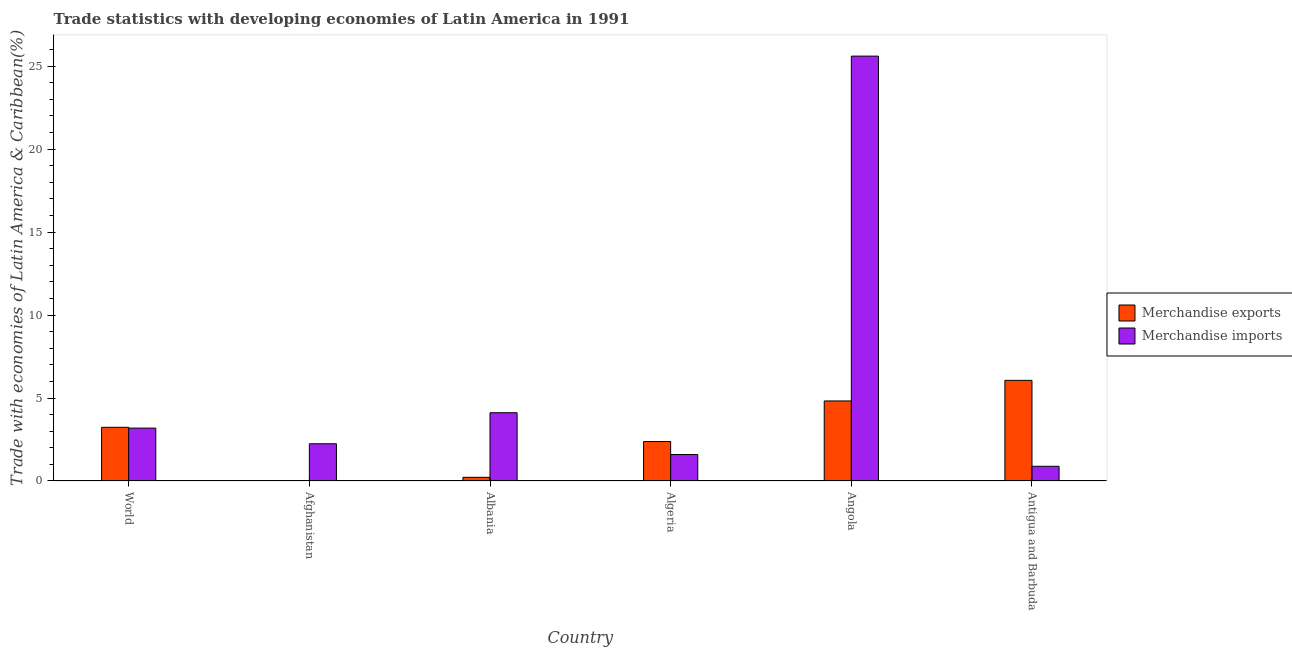How many groups of bars are there?
Give a very brief answer. 6. Are the number of bars on each tick of the X-axis equal?
Give a very brief answer. Yes. How many bars are there on the 5th tick from the right?
Your answer should be compact. 2. What is the label of the 1st group of bars from the left?
Offer a very short reply. World. In how many cases, is the number of bars for a given country not equal to the number of legend labels?
Offer a very short reply. 0. What is the merchandise exports in Angola?
Make the answer very short. 4.82. Across all countries, what is the maximum merchandise exports?
Provide a short and direct response. 6.06. Across all countries, what is the minimum merchandise imports?
Keep it short and to the point. 0.89. In which country was the merchandise imports maximum?
Provide a succinct answer. Angola. In which country was the merchandise exports minimum?
Offer a very short reply. Afghanistan. What is the total merchandise imports in the graph?
Offer a very short reply. 37.63. What is the difference between the merchandise imports in Afghanistan and that in Albania?
Offer a very short reply. -1.87. What is the difference between the merchandise imports in Angola and the merchandise exports in Algeria?
Ensure brevity in your answer.  23.22. What is the average merchandise exports per country?
Make the answer very short. 2.79. What is the difference between the merchandise imports and merchandise exports in World?
Offer a very short reply. -0.05. What is the ratio of the merchandise imports in Afghanistan to that in Albania?
Keep it short and to the point. 0.55. Is the difference between the merchandise imports in Albania and World greater than the difference between the merchandise exports in Albania and World?
Keep it short and to the point. Yes. What is the difference between the highest and the second highest merchandise exports?
Provide a short and direct response. 1.24. What is the difference between the highest and the lowest merchandise imports?
Provide a short and direct response. 24.72. Is the sum of the merchandise exports in Afghanistan and Angola greater than the maximum merchandise imports across all countries?
Provide a succinct answer. No. What does the 1st bar from the left in Antigua and Barbuda represents?
Make the answer very short. Merchandise exports. What does the 2nd bar from the right in Albania represents?
Make the answer very short. Merchandise exports. Does the graph contain any zero values?
Ensure brevity in your answer.  No. What is the title of the graph?
Ensure brevity in your answer.  Trade statistics with developing economies of Latin America in 1991. What is the label or title of the Y-axis?
Ensure brevity in your answer.  Trade with economies of Latin America & Caribbean(%). What is the Trade with economies of Latin America & Caribbean(%) in Merchandise exports in World?
Give a very brief answer. 3.23. What is the Trade with economies of Latin America & Caribbean(%) of Merchandise imports in World?
Ensure brevity in your answer.  3.19. What is the Trade with economies of Latin America & Caribbean(%) in Merchandise exports in Afghanistan?
Offer a terse response. 0.01. What is the Trade with economies of Latin America & Caribbean(%) in Merchandise imports in Afghanistan?
Your answer should be very brief. 2.24. What is the Trade with economies of Latin America & Caribbean(%) of Merchandise exports in Albania?
Make the answer very short. 0.22. What is the Trade with economies of Latin America & Caribbean(%) of Merchandise imports in Albania?
Give a very brief answer. 4.11. What is the Trade with economies of Latin America & Caribbean(%) in Merchandise exports in Algeria?
Make the answer very short. 2.38. What is the Trade with economies of Latin America & Caribbean(%) of Merchandise imports in Algeria?
Provide a succinct answer. 1.59. What is the Trade with economies of Latin America & Caribbean(%) of Merchandise exports in Angola?
Keep it short and to the point. 4.82. What is the Trade with economies of Latin America & Caribbean(%) of Merchandise imports in Angola?
Offer a very short reply. 25.6. What is the Trade with economies of Latin America & Caribbean(%) in Merchandise exports in Antigua and Barbuda?
Your answer should be compact. 6.06. What is the Trade with economies of Latin America & Caribbean(%) in Merchandise imports in Antigua and Barbuda?
Make the answer very short. 0.89. Across all countries, what is the maximum Trade with economies of Latin America & Caribbean(%) of Merchandise exports?
Your response must be concise. 6.06. Across all countries, what is the maximum Trade with economies of Latin America & Caribbean(%) in Merchandise imports?
Provide a short and direct response. 25.6. Across all countries, what is the minimum Trade with economies of Latin America & Caribbean(%) in Merchandise exports?
Give a very brief answer. 0.01. Across all countries, what is the minimum Trade with economies of Latin America & Caribbean(%) in Merchandise imports?
Offer a terse response. 0.89. What is the total Trade with economies of Latin America & Caribbean(%) of Merchandise exports in the graph?
Give a very brief answer. 16.73. What is the total Trade with economies of Latin America & Caribbean(%) in Merchandise imports in the graph?
Make the answer very short. 37.63. What is the difference between the Trade with economies of Latin America & Caribbean(%) of Merchandise exports in World and that in Afghanistan?
Offer a terse response. 3.22. What is the difference between the Trade with economies of Latin America & Caribbean(%) in Merchandise imports in World and that in Afghanistan?
Provide a succinct answer. 0.94. What is the difference between the Trade with economies of Latin America & Caribbean(%) of Merchandise exports in World and that in Albania?
Your response must be concise. 3.01. What is the difference between the Trade with economies of Latin America & Caribbean(%) in Merchandise imports in World and that in Albania?
Provide a short and direct response. -0.92. What is the difference between the Trade with economies of Latin America & Caribbean(%) in Merchandise exports in World and that in Algeria?
Ensure brevity in your answer.  0.86. What is the difference between the Trade with economies of Latin America & Caribbean(%) of Merchandise imports in World and that in Algeria?
Provide a succinct answer. 1.59. What is the difference between the Trade with economies of Latin America & Caribbean(%) in Merchandise exports in World and that in Angola?
Provide a short and direct response. -1.59. What is the difference between the Trade with economies of Latin America & Caribbean(%) of Merchandise imports in World and that in Angola?
Ensure brevity in your answer.  -22.42. What is the difference between the Trade with economies of Latin America & Caribbean(%) in Merchandise exports in World and that in Antigua and Barbuda?
Your answer should be compact. -2.83. What is the difference between the Trade with economies of Latin America & Caribbean(%) in Merchandise imports in World and that in Antigua and Barbuda?
Give a very brief answer. 2.3. What is the difference between the Trade with economies of Latin America & Caribbean(%) in Merchandise exports in Afghanistan and that in Albania?
Give a very brief answer. -0.21. What is the difference between the Trade with economies of Latin America & Caribbean(%) in Merchandise imports in Afghanistan and that in Albania?
Your answer should be compact. -1.87. What is the difference between the Trade with economies of Latin America & Caribbean(%) of Merchandise exports in Afghanistan and that in Algeria?
Make the answer very short. -2.37. What is the difference between the Trade with economies of Latin America & Caribbean(%) in Merchandise imports in Afghanistan and that in Algeria?
Offer a terse response. 0.65. What is the difference between the Trade with economies of Latin America & Caribbean(%) of Merchandise exports in Afghanistan and that in Angola?
Make the answer very short. -4.81. What is the difference between the Trade with economies of Latin America & Caribbean(%) in Merchandise imports in Afghanistan and that in Angola?
Offer a terse response. -23.36. What is the difference between the Trade with economies of Latin America & Caribbean(%) in Merchandise exports in Afghanistan and that in Antigua and Barbuda?
Offer a terse response. -6.05. What is the difference between the Trade with economies of Latin America & Caribbean(%) of Merchandise imports in Afghanistan and that in Antigua and Barbuda?
Provide a short and direct response. 1.36. What is the difference between the Trade with economies of Latin America & Caribbean(%) in Merchandise exports in Albania and that in Algeria?
Provide a short and direct response. -2.16. What is the difference between the Trade with economies of Latin America & Caribbean(%) of Merchandise imports in Albania and that in Algeria?
Provide a short and direct response. 2.52. What is the difference between the Trade with economies of Latin America & Caribbean(%) in Merchandise exports in Albania and that in Angola?
Ensure brevity in your answer.  -4.6. What is the difference between the Trade with economies of Latin America & Caribbean(%) of Merchandise imports in Albania and that in Angola?
Provide a succinct answer. -21.49. What is the difference between the Trade with economies of Latin America & Caribbean(%) of Merchandise exports in Albania and that in Antigua and Barbuda?
Provide a short and direct response. -5.84. What is the difference between the Trade with economies of Latin America & Caribbean(%) of Merchandise imports in Albania and that in Antigua and Barbuda?
Provide a succinct answer. 3.23. What is the difference between the Trade with economies of Latin America & Caribbean(%) in Merchandise exports in Algeria and that in Angola?
Your response must be concise. -2.44. What is the difference between the Trade with economies of Latin America & Caribbean(%) of Merchandise imports in Algeria and that in Angola?
Offer a terse response. -24.01. What is the difference between the Trade with economies of Latin America & Caribbean(%) of Merchandise exports in Algeria and that in Antigua and Barbuda?
Keep it short and to the point. -3.68. What is the difference between the Trade with economies of Latin America & Caribbean(%) of Merchandise imports in Algeria and that in Antigua and Barbuda?
Give a very brief answer. 0.71. What is the difference between the Trade with economies of Latin America & Caribbean(%) in Merchandise exports in Angola and that in Antigua and Barbuda?
Give a very brief answer. -1.24. What is the difference between the Trade with economies of Latin America & Caribbean(%) of Merchandise imports in Angola and that in Antigua and Barbuda?
Keep it short and to the point. 24.72. What is the difference between the Trade with economies of Latin America & Caribbean(%) in Merchandise exports in World and the Trade with economies of Latin America & Caribbean(%) in Merchandise imports in Afghanistan?
Your answer should be very brief. 0.99. What is the difference between the Trade with economies of Latin America & Caribbean(%) of Merchandise exports in World and the Trade with economies of Latin America & Caribbean(%) of Merchandise imports in Albania?
Your response must be concise. -0.88. What is the difference between the Trade with economies of Latin America & Caribbean(%) of Merchandise exports in World and the Trade with economies of Latin America & Caribbean(%) of Merchandise imports in Algeria?
Your answer should be compact. 1.64. What is the difference between the Trade with economies of Latin America & Caribbean(%) of Merchandise exports in World and the Trade with economies of Latin America & Caribbean(%) of Merchandise imports in Angola?
Offer a terse response. -22.37. What is the difference between the Trade with economies of Latin America & Caribbean(%) in Merchandise exports in World and the Trade with economies of Latin America & Caribbean(%) in Merchandise imports in Antigua and Barbuda?
Your answer should be compact. 2.35. What is the difference between the Trade with economies of Latin America & Caribbean(%) of Merchandise exports in Afghanistan and the Trade with economies of Latin America & Caribbean(%) of Merchandise imports in Albania?
Make the answer very short. -4.1. What is the difference between the Trade with economies of Latin America & Caribbean(%) in Merchandise exports in Afghanistan and the Trade with economies of Latin America & Caribbean(%) in Merchandise imports in Algeria?
Your response must be concise. -1.58. What is the difference between the Trade with economies of Latin America & Caribbean(%) in Merchandise exports in Afghanistan and the Trade with economies of Latin America & Caribbean(%) in Merchandise imports in Angola?
Give a very brief answer. -25.59. What is the difference between the Trade with economies of Latin America & Caribbean(%) in Merchandise exports in Afghanistan and the Trade with economies of Latin America & Caribbean(%) in Merchandise imports in Antigua and Barbuda?
Offer a terse response. -0.88. What is the difference between the Trade with economies of Latin America & Caribbean(%) in Merchandise exports in Albania and the Trade with economies of Latin America & Caribbean(%) in Merchandise imports in Algeria?
Your response must be concise. -1.37. What is the difference between the Trade with economies of Latin America & Caribbean(%) of Merchandise exports in Albania and the Trade with economies of Latin America & Caribbean(%) of Merchandise imports in Angola?
Keep it short and to the point. -25.38. What is the difference between the Trade with economies of Latin America & Caribbean(%) in Merchandise exports in Albania and the Trade with economies of Latin America & Caribbean(%) in Merchandise imports in Antigua and Barbuda?
Give a very brief answer. -0.67. What is the difference between the Trade with economies of Latin America & Caribbean(%) in Merchandise exports in Algeria and the Trade with economies of Latin America & Caribbean(%) in Merchandise imports in Angola?
Make the answer very short. -23.22. What is the difference between the Trade with economies of Latin America & Caribbean(%) of Merchandise exports in Algeria and the Trade with economies of Latin America & Caribbean(%) of Merchandise imports in Antigua and Barbuda?
Your response must be concise. 1.49. What is the difference between the Trade with economies of Latin America & Caribbean(%) of Merchandise exports in Angola and the Trade with economies of Latin America & Caribbean(%) of Merchandise imports in Antigua and Barbuda?
Your answer should be very brief. 3.94. What is the average Trade with economies of Latin America & Caribbean(%) in Merchandise exports per country?
Make the answer very short. 2.79. What is the average Trade with economies of Latin America & Caribbean(%) in Merchandise imports per country?
Ensure brevity in your answer.  6.27. What is the difference between the Trade with economies of Latin America & Caribbean(%) in Merchandise exports and Trade with economies of Latin America & Caribbean(%) in Merchandise imports in World?
Your answer should be very brief. 0.05. What is the difference between the Trade with economies of Latin America & Caribbean(%) of Merchandise exports and Trade with economies of Latin America & Caribbean(%) of Merchandise imports in Afghanistan?
Ensure brevity in your answer.  -2.23. What is the difference between the Trade with economies of Latin America & Caribbean(%) in Merchandise exports and Trade with economies of Latin America & Caribbean(%) in Merchandise imports in Albania?
Ensure brevity in your answer.  -3.89. What is the difference between the Trade with economies of Latin America & Caribbean(%) in Merchandise exports and Trade with economies of Latin America & Caribbean(%) in Merchandise imports in Algeria?
Your answer should be compact. 0.79. What is the difference between the Trade with economies of Latin America & Caribbean(%) in Merchandise exports and Trade with economies of Latin America & Caribbean(%) in Merchandise imports in Angola?
Give a very brief answer. -20.78. What is the difference between the Trade with economies of Latin America & Caribbean(%) in Merchandise exports and Trade with economies of Latin America & Caribbean(%) in Merchandise imports in Antigua and Barbuda?
Make the answer very short. 5.18. What is the ratio of the Trade with economies of Latin America & Caribbean(%) of Merchandise exports in World to that in Afghanistan?
Ensure brevity in your answer.  325.87. What is the ratio of the Trade with economies of Latin America & Caribbean(%) of Merchandise imports in World to that in Afghanistan?
Give a very brief answer. 1.42. What is the ratio of the Trade with economies of Latin America & Caribbean(%) of Merchandise exports in World to that in Albania?
Your response must be concise. 14.66. What is the ratio of the Trade with economies of Latin America & Caribbean(%) in Merchandise imports in World to that in Albania?
Keep it short and to the point. 0.78. What is the ratio of the Trade with economies of Latin America & Caribbean(%) of Merchandise exports in World to that in Algeria?
Offer a terse response. 1.36. What is the ratio of the Trade with economies of Latin America & Caribbean(%) of Merchandise imports in World to that in Algeria?
Your answer should be compact. 2. What is the ratio of the Trade with economies of Latin America & Caribbean(%) of Merchandise exports in World to that in Angola?
Provide a succinct answer. 0.67. What is the ratio of the Trade with economies of Latin America & Caribbean(%) in Merchandise imports in World to that in Angola?
Keep it short and to the point. 0.12. What is the ratio of the Trade with economies of Latin America & Caribbean(%) of Merchandise exports in World to that in Antigua and Barbuda?
Your response must be concise. 0.53. What is the ratio of the Trade with economies of Latin America & Caribbean(%) in Merchandise imports in World to that in Antigua and Barbuda?
Your response must be concise. 3.6. What is the ratio of the Trade with economies of Latin America & Caribbean(%) of Merchandise exports in Afghanistan to that in Albania?
Your response must be concise. 0.04. What is the ratio of the Trade with economies of Latin America & Caribbean(%) of Merchandise imports in Afghanistan to that in Albania?
Keep it short and to the point. 0.55. What is the ratio of the Trade with economies of Latin America & Caribbean(%) in Merchandise exports in Afghanistan to that in Algeria?
Provide a succinct answer. 0. What is the ratio of the Trade with economies of Latin America & Caribbean(%) of Merchandise imports in Afghanistan to that in Algeria?
Ensure brevity in your answer.  1.41. What is the ratio of the Trade with economies of Latin America & Caribbean(%) in Merchandise exports in Afghanistan to that in Angola?
Provide a short and direct response. 0. What is the ratio of the Trade with economies of Latin America & Caribbean(%) in Merchandise imports in Afghanistan to that in Angola?
Keep it short and to the point. 0.09. What is the ratio of the Trade with economies of Latin America & Caribbean(%) in Merchandise exports in Afghanistan to that in Antigua and Barbuda?
Ensure brevity in your answer.  0. What is the ratio of the Trade with economies of Latin America & Caribbean(%) in Merchandise imports in Afghanistan to that in Antigua and Barbuda?
Your answer should be compact. 2.53. What is the ratio of the Trade with economies of Latin America & Caribbean(%) in Merchandise exports in Albania to that in Algeria?
Offer a very short reply. 0.09. What is the ratio of the Trade with economies of Latin America & Caribbean(%) of Merchandise imports in Albania to that in Algeria?
Provide a short and direct response. 2.58. What is the ratio of the Trade with economies of Latin America & Caribbean(%) of Merchandise exports in Albania to that in Angola?
Make the answer very short. 0.05. What is the ratio of the Trade with economies of Latin America & Caribbean(%) in Merchandise imports in Albania to that in Angola?
Ensure brevity in your answer.  0.16. What is the ratio of the Trade with economies of Latin America & Caribbean(%) in Merchandise exports in Albania to that in Antigua and Barbuda?
Your response must be concise. 0.04. What is the ratio of the Trade with economies of Latin America & Caribbean(%) in Merchandise imports in Albania to that in Antigua and Barbuda?
Offer a terse response. 4.64. What is the ratio of the Trade with economies of Latin America & Caribbean(%) of Merchandise exports in Algeria to that in Angola?
Keep it short and to the point. 0.49. What is the ratio of the Trade with economies of Latin America & Caribbean(%) of Merchandise imports in Algeria to that in Angola?
Offer a very short reply. 0.06. What is the ratio of the Trade with economies of Latin America & Caribbean(%) of Merchandise exports in Algeria to that in Antigua and Barbuda?
Ensure brevity in your answer.  0.39. What is the ratio of the Trade with economies of Latin America & Caribbean(%) in Merchandise imports in Algeria to that in Antigua and Barbuda?
Keep it short and to the point. 1.8. What is the ratio of the Trade with economies of Latin America & Caribbean(%) of Merchandise exports in Angola to that in Antigua and Barbuda?
Your answer should be compact. 0.8. What is the ratio of the Trade with economies of Latin America & Caribbean(%) in Merchandise imports in Angola to that in Antigua and Barbuda?
Provide a succinct answer. 28.89. What is the difference between the highest and the second highest Trade with economies of Latin America & Caribbean(%) in Merchandise exports?
Your answer should be compact. 1.24. What is the difference between the highest and the second highest Trade with economies of Latin America & Caribbean(%) of Merchandise imports?
Your answer should be very brief. 21.49. What is the difference between the highest and the lowest Trade with economies of Latin America & Caribbean(%) in Merchandise exports?
Provide a short and direct response. 6.05. What is the difference between the highest and the lowest Trade with economies of Latin America & Caribbean(%) of Merchandise imports?
Provide a short and direct response. 24.72. 